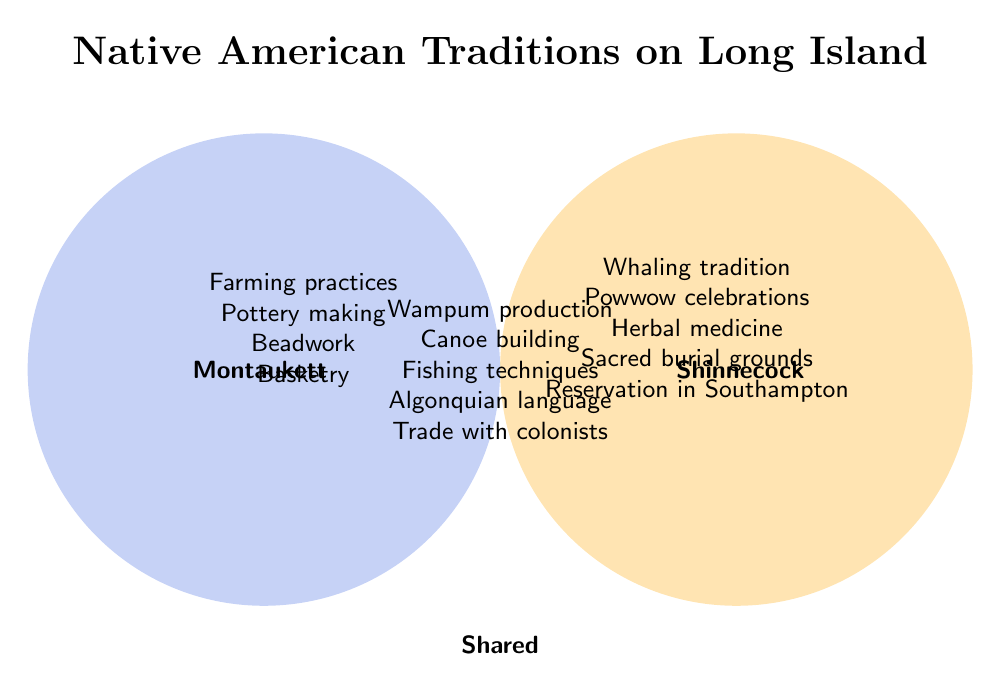What are the shared traditions between the Shinnecock and Montaukett tribes? The elements found in the overlapping area represent shared traditions.
Answer: Wampum production, Canoe building, Fishing techniques, Algonquian language, Trade with colonists Which tribe has the tradition of Powwow celebrations? The element appears in the Shinnecock circle and does not overlap with the Montaukett circle.
Answer: Shinnecock What practices are unique to the Montaukett tribe? Elements that are solely within the Montaukett circle are unique to this tribe.
Answer: Farming practices, Pottery making, Beadwork, Basketry How many shared practices between the Shinnecock and Montaukett tribes are listed? Count the practices listed in the overlapping section.
Answer: 5 Which tribe is associated with having a reservation in Southampton? The element indicating the reservation in Southampton is within the Shinnecock circle.
Answer: Shinnecock Describe the tribes' relationship with colonists mentioned in the diagram. The specific traditions or practices related to colonists can be found in the overlapping area.
Answer: Trade with colonists What is the tradition associated with herbal medicine attributed to? The term "Herbal medicine" is found solely within the Shinnecock circle.
Answer: Shinnecock Between Shinnecock and Montaukett, which tribe is linked with pottery making? The term "Pottery making" is found within the Montaukett circle.
Answer: Montaukett Any elements listed that involve construction? Identify any terms related to building or crafting from any circle.
Answer: Canoe building (shared), Pottery making (Montaukett) 